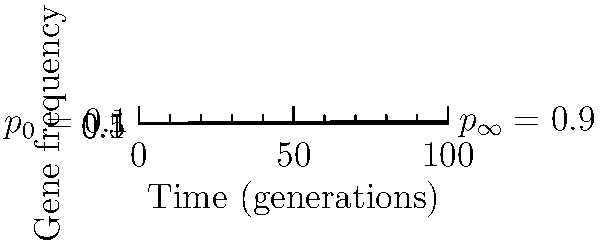The graph shows the change in frequency of a beneficial allele in a population over time. Assuming Hardy-Weinberg equilibrium and no other evolutionary forces except selection, what is the selection coefficient ($s$) for this allele if the initial frequency ($p_0$) is 0.1 and the equilibrium frequency ($p_{\infty}$) is 0.9? To solve this problem, we'll use the formula for gene frequency change under selection in Hardy-Weinberg equilibrium:

1) The formula for gene frequency change is:
   $\frac{dp}{dt} = sp(1-p)$

2) At equilibrium, $\frac{dp}{dt} = 0$, so $p_{\infty} = 1$

3) The solution to this differential equation is:
   $p(t) = \frac{p_0}{p_0 + (1-p_0)e^{-st}}$

4) As $t \to \infty$, $p(t) \to p_{\infty}$:
   $p_{\infty} = \frac{p_0}{p_0 + (1-p_0)e^{-s\infty}} = \frac{p_0}{p_0} = 1$

5) However, in this case, $p_{\infty} = 0.9$, not 1. This suggests there's some opposing force, like migration or mutation.

6) We can modify our equation to account for this:
   $p(t) = p_{\infty} - (p_{\infty} - p_0)e^{-st}$

7) From the graph, we can estimate that it takes about 60 generations to reach 63% of the way from $p_0$ to $p_{\infty}$

8) This corresponds to one time constant ($\tau$) in the exponential function:
   $1 - e^{-1} \approx 0.63$

9) Therefore, $s\tau = 1$, or $s = \frac{1}{\tau} \approx \frac{1}{60} \approx 0.017$
Answer: $s \approx 0.017$ 